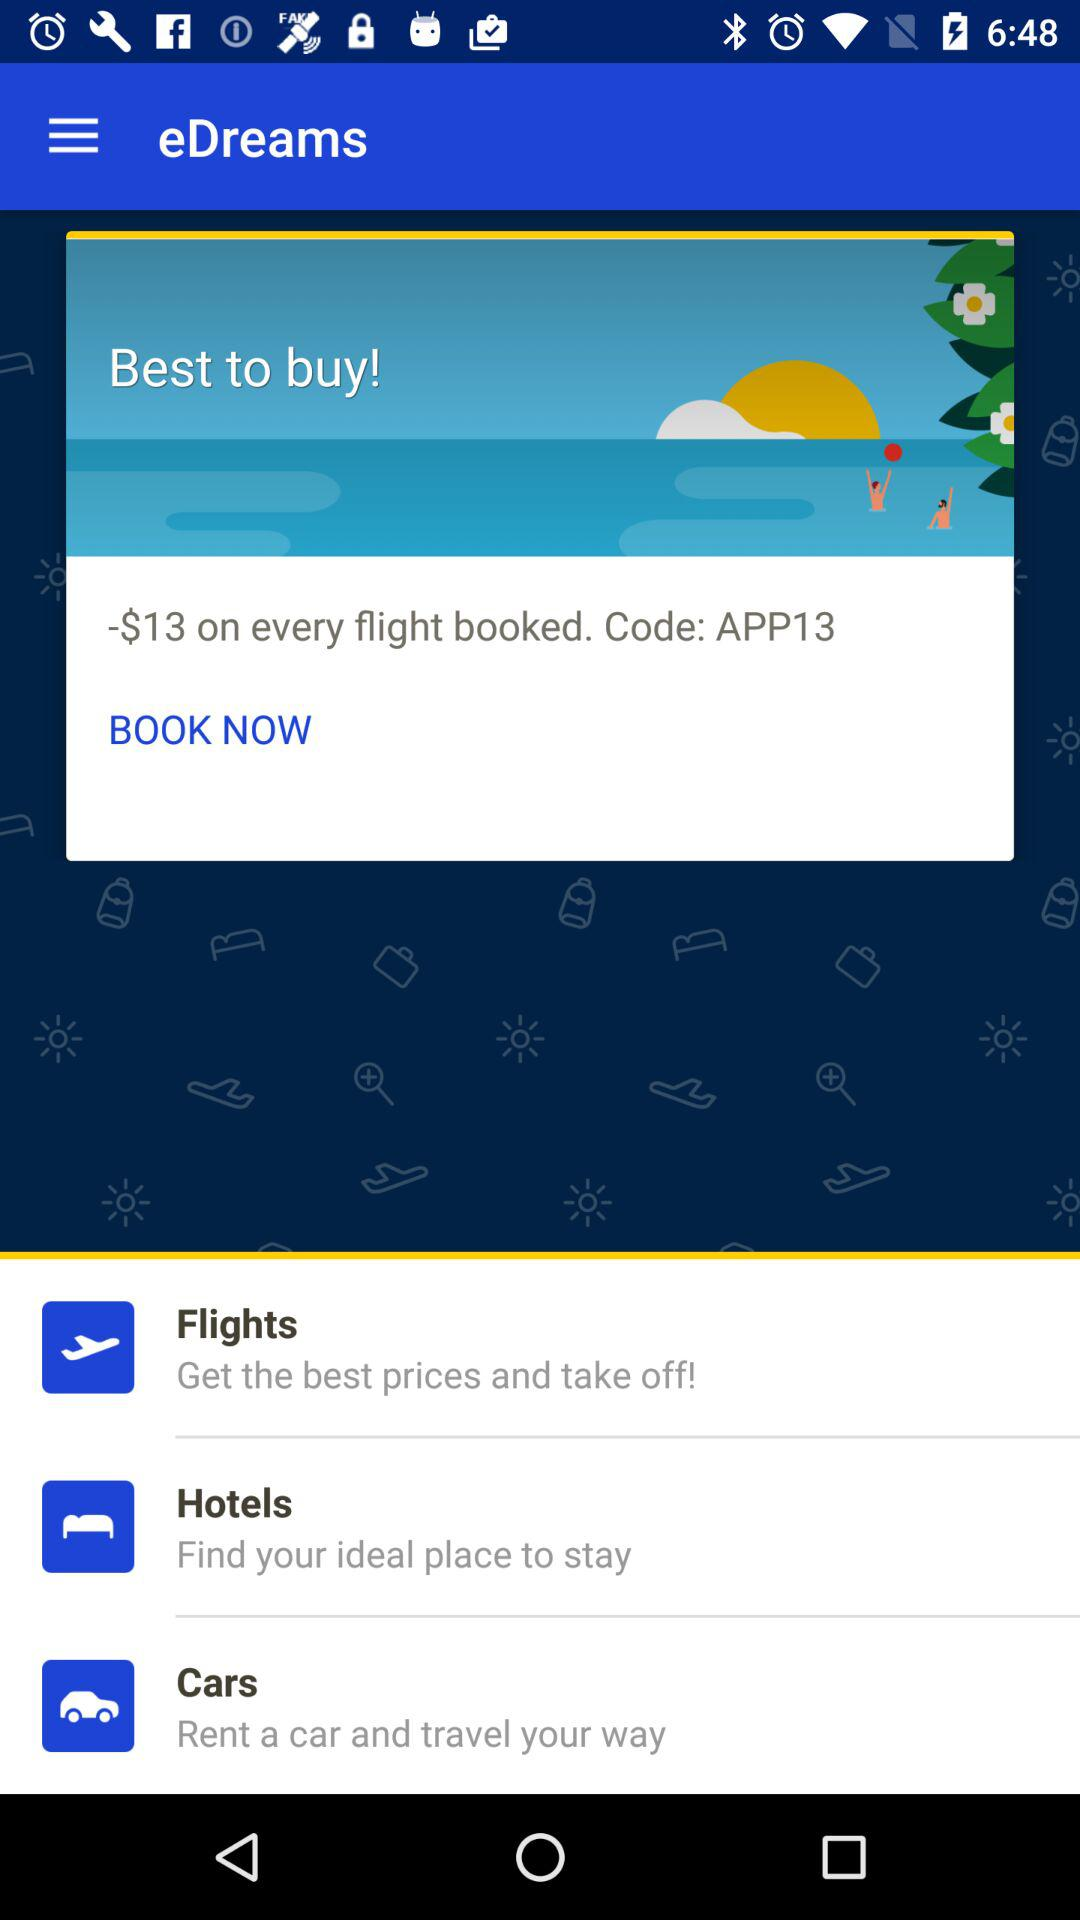What is the code used for the offer? The code is APP13. 